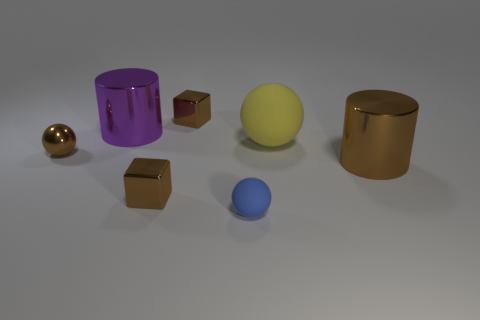What is the size of the metallic block on the left side of the block behind the big metal thing right of the purple object?
Provide a short and direct response. Small. How many other objects are the same color as the metal sphere?
Give a very brief answer. 3. What is the shape of the blue thing that is the same size as the brown metallic ball?
Offer a terse response. Sphere. What size is the matte ball behind the large brown cylinder?
Make the answer very short. Large. There is a large cylinder left of the large matte sphere; is it the same color as the metallic thing in front of the large brown cylinder?
Your response must be concise. No. What is the large thing that is left of the cube in front of the metallic cylinder right of the big rubber sphere made of?
Provide a succinct answer. Metal. Are there any brown blocks that have the same size as the blue rubber ball?
Your answer should be very brief. Yes. There is a brown sphere that is the same size as the blue matte object; what is it made of?
Ensure brevity in your answer.  Metal. What shape is the large shiny thing in front of the purple cylinder?
Provide a short and direct response. Cylinder. Is the material of the small ball in front of the large brown metallic object the same as the large cylinder behind the brown metallic ball?
Offer a terse response. No. 